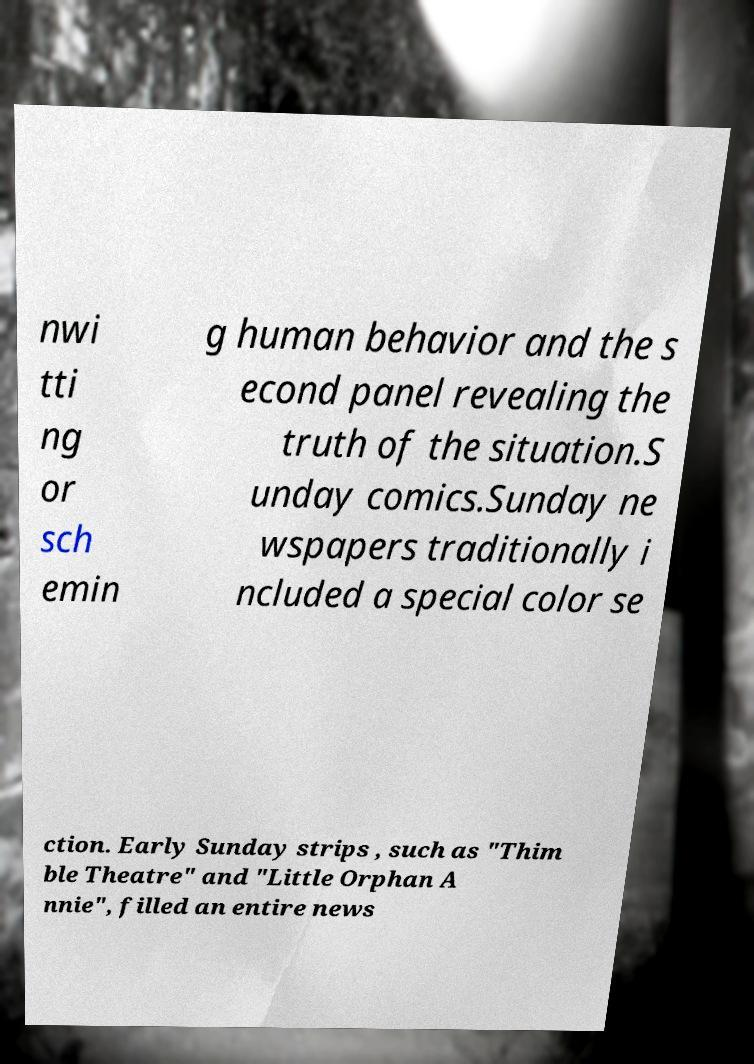Can you read and provide the text displayed in the image?This photo seems to have some interesting text. Can you extract and type it out for me? nwi tti ng or sch emin g human behavior and the s econd panel revealing the truth of the situation.S unday comics.Sunday ne wspapers traditionally i ncluded a special color se ction. Early Sunday strips , such as "Thim ble Theatre" and "Little Orphan A nnie", filled an entire news 